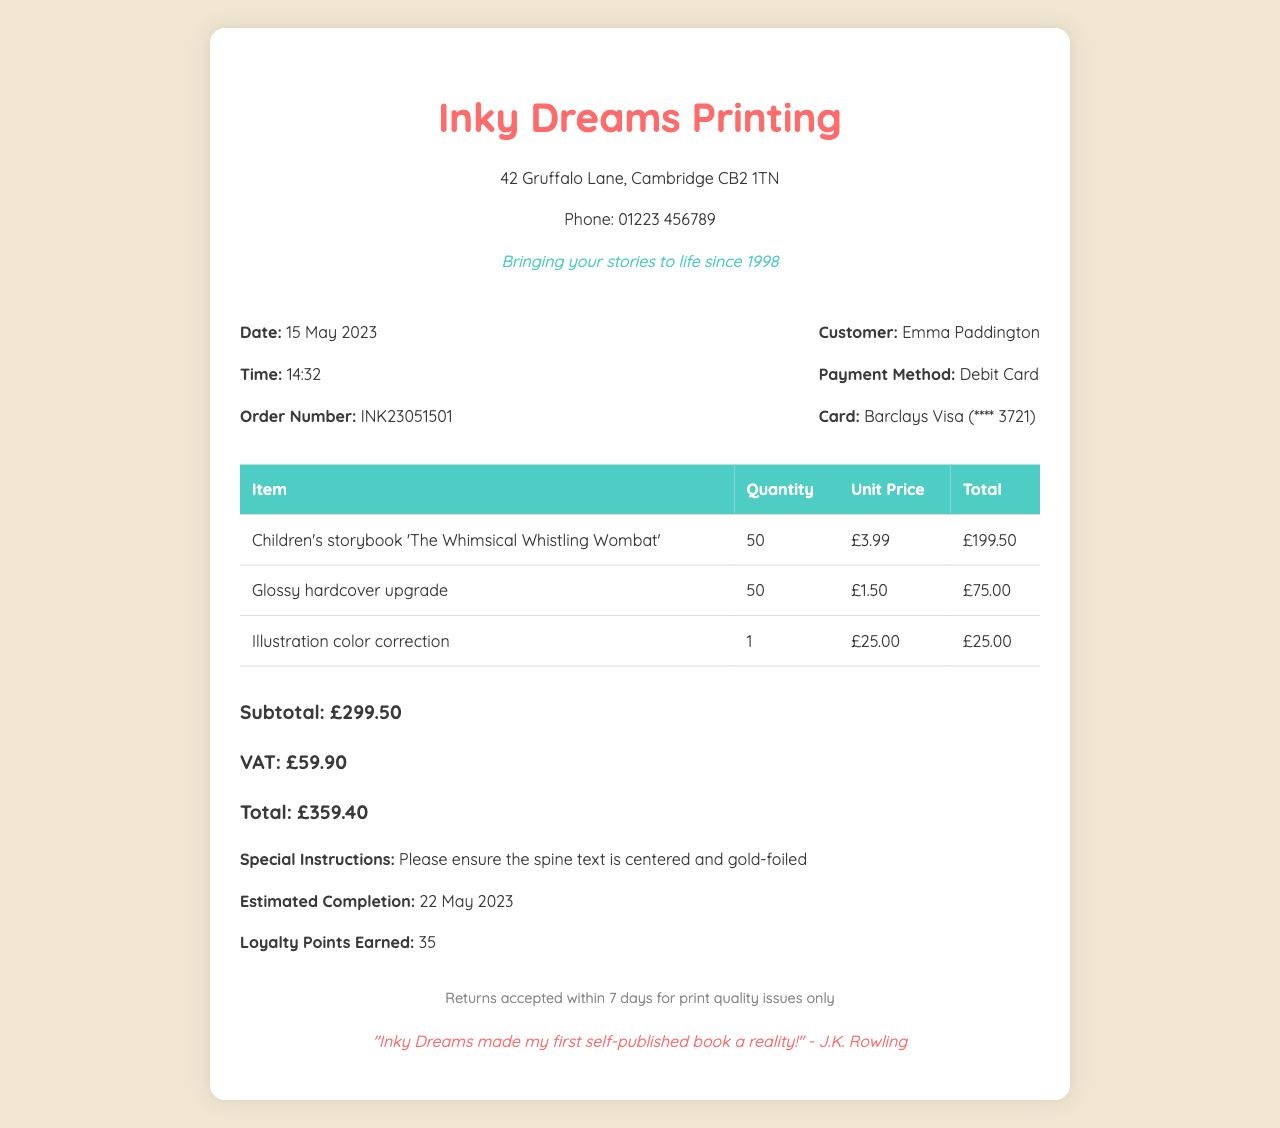What is the shop's name? The shop's name is prominently displayed at the top of the receipt.
Answer: Inky Dreams Printing What is the order number? The order number is a unique identifier listed for the transaction.
Answer: INK23051501 What is the total amount? The total amount is the sum of the subtotal and VAT, clearly indicated at the bottom of the receipt.
Answer: £359.40 How many loyalty points were earned? The earned loyalty points are noted towards the end of the document.
Answer: 35 What special instructions were included? Special instructions offer specific requests made for the order and are included in a designated section.
Answer: Please ensure the spine text is centered and gold-foiled What was the quantity of the hardcover upgrade? The quantity is listed in the order details section and indicates how many were purchased.
Answer: 50 What is the estimated completion date? The estimated completion date indicates when the order will be ready and is specified within the document.
Answer: 22 May 2023 What type of card was used for payment? The card type is noted under the payment method section of the receipt.
Answer: Barclays Visa What is the return policy? The return policy describes the conditions under which returns are accepted and is included in the footer.
Answer: Returns accepted within 7 days for print quality issues only Who gave the testimonial? The testimonial is a quote from someone who used the shop’s services, and is included towards the end of the receipt.
Answer: J.K. Rowling 